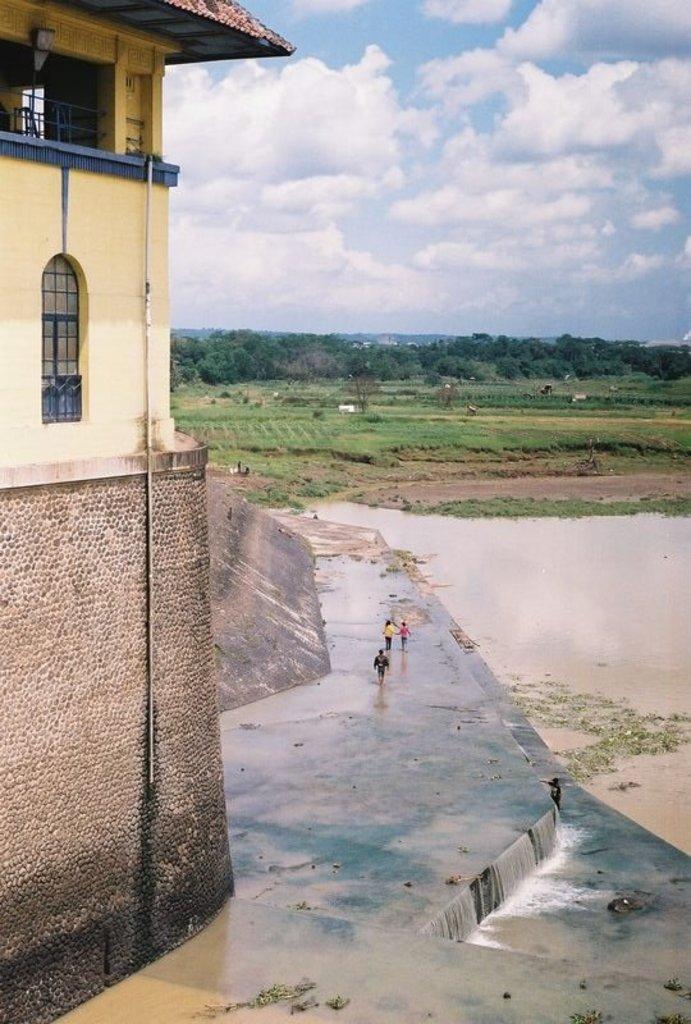In one or two sentences, can you explain what this image depicts? As we can see in the image there is water, few people here and there, building, grass and trees. On the top there is sky and clouds. 